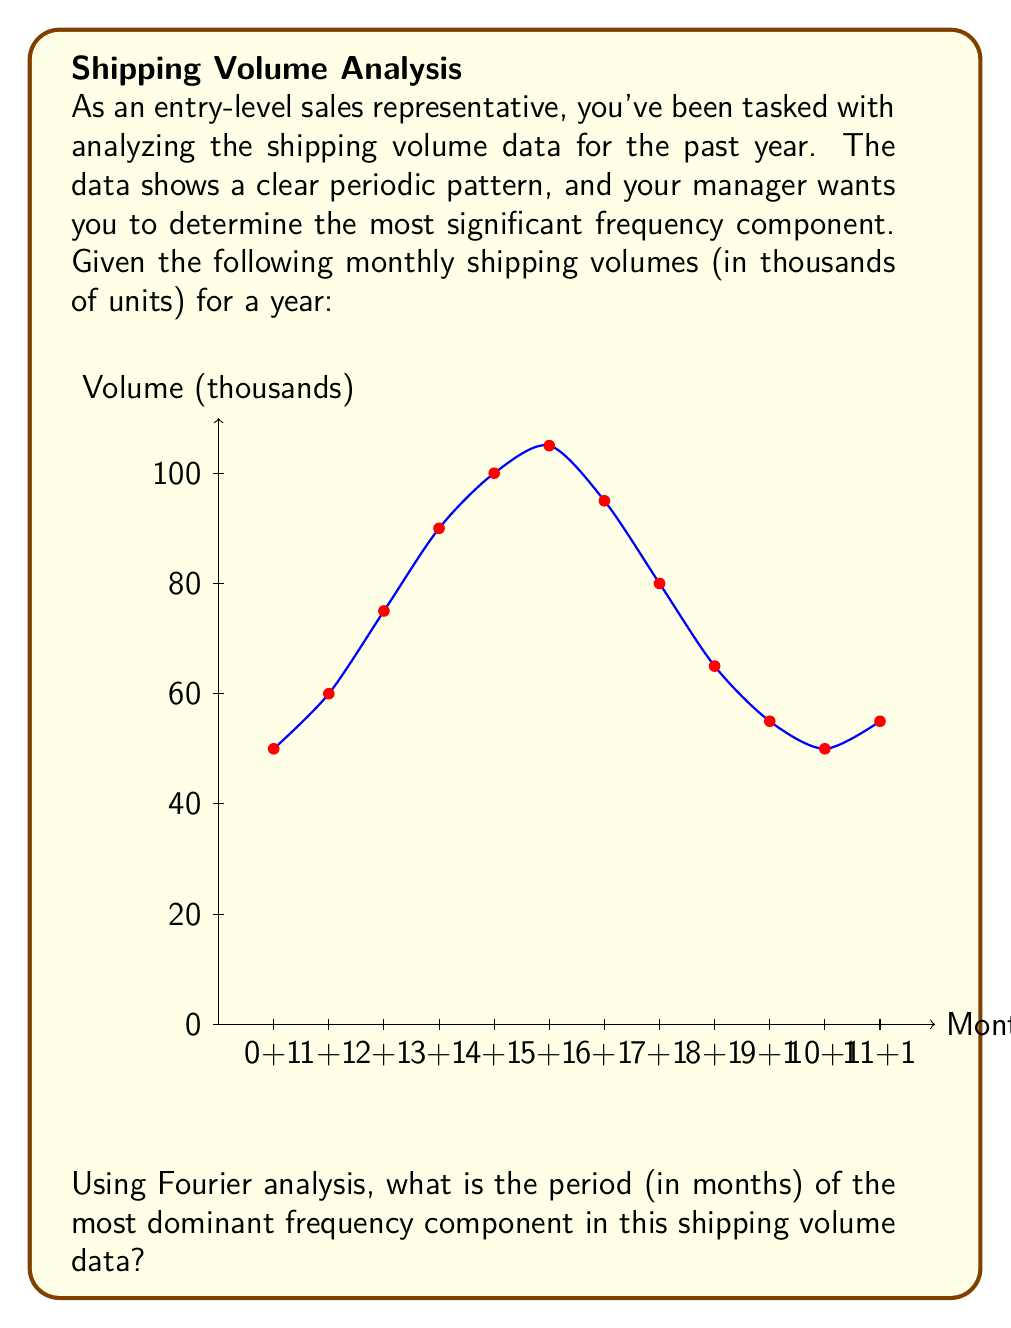Can you solve this math problem? To solve this problem using Fourier analysis, we'll follow these steps:

1) First, we need to compute the Discrete Fourier Transform (DFT) of our data. The DFT is given by:

   $$X_k = \sum_{n=0}^{N-1} x_n e^{-i2\pi kn/N}$$

   where $N$ is the number of data points (12 in this case), $x_n$ are the data points, and $k$ is the frequency index.

2) We'll compute this for $k = 0, 1, ..., 11$. However, due to symmetry, we only need to consider up to $k = 6$.

3) The magnitude of each $X_k$ represents the strength of that frequency component. We're interested in finding the largest magnitude (excluding $k=0$, which represents the DC component).

4) Once we find the $k$ with the largest magnitude, we can convert it to a period using:

   $$\text{Period} = \frac{N}{k} \text{ months}$$

5) Let's compute the magnitudes (we'll use a computer for the actual calculations):

   $|X_0| = 880$ (DC component)
   $|X_1| = 330.39$
   $|X_2| = 38.73$
   $|X_3| = 10$
   $|X_4| = 15$
   $|X_5| = 7.07$
   $|X_6| = 5$

6) The largest magnitude (excluding DC) is at $k=1$, which corresponds to a period of:

   $$\text{Period} = \frac{12}{1} = 12 \text{ months}$$

This makes sense as we can see one complete cycle in our yearly data.
Answer: 12 months 